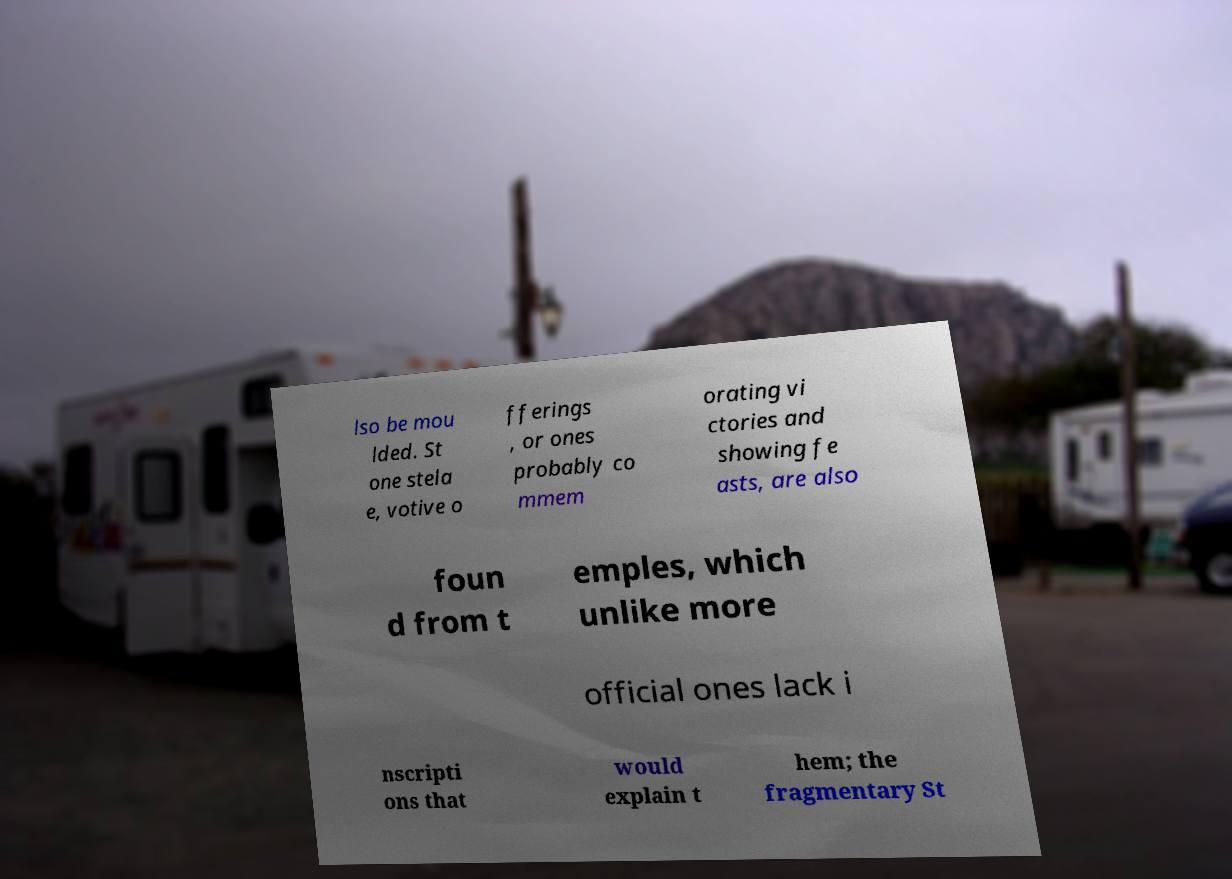Please read and relay the text visible in this image. What does it say? lso be mou lded. St one stela e, votive o fferings , or ones probably co mmem orating vi ctories and showing fe asts, are also foun d from t emples, which unlike more official ones lack i nscripti ons that would explain t hem; the fragmentary St 